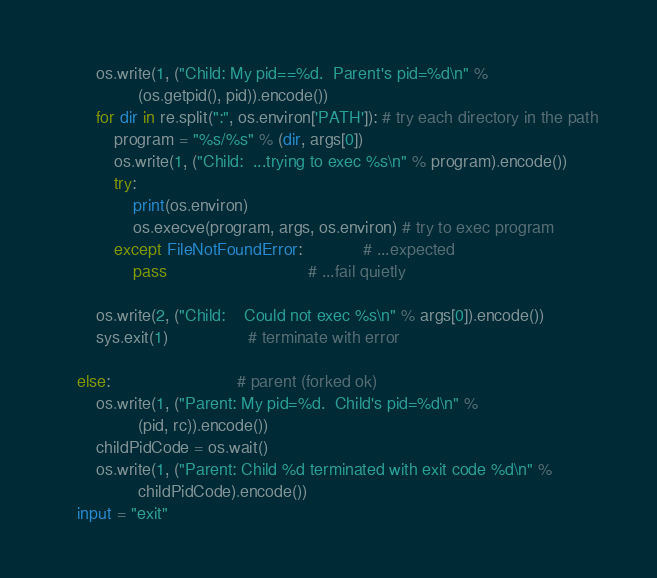Convert code to text. <code><loc_0><loc_0><loc_500><loc_500><_Python_>        os.write(1, ("Child: My pid==%d.  Parent's pid=%d\n" % 
                 (os.getpid(), pid)).encode())
        for dir in re.split(":", os.environ['PATH']): # try each directory in the path
            program = "%s/%s" % (dir, args[0])
            os.write(1, ("Child:  ...trying to exec %s\n" % program).encode())
            try:
                print(os.environ)
                os.execve(program, args, os.environ) # try to exec program
            except FileNotFoundError:             # ...expected
                pass                              # ...fail quietly

        os.write(2, ("Child:    Could not exec %s\n" % args[0]).encode())
        sys.exit(1)                 # terminate with error

    else:                           # parent (forked ok)
        os.write(1, ("Parent: My pid=%d.  Child's pid=%d\n" % 
                 (pid, rc)).encode())
        childPidCode = os.wait()
        os.write(1, ("Parent: Child %d terminated with exit code %d\n" % 
                 childPidCode).encode())
    input = "exit"
</code> 